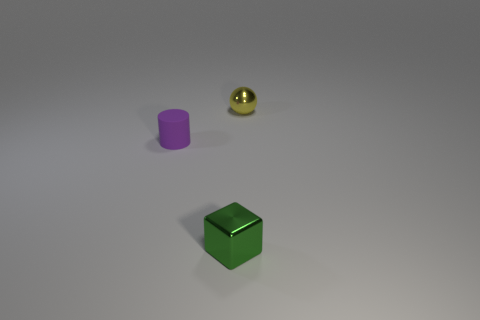Is there anything else that is made of the same material as the cylinder?
Make the answer very short. No. Are there any tiny green objects to the left of the yellow metal thing behind the small purple matte cylinder?
Provide a short and direct response. Yes. What number of things are small metal things behind the purple matte thing or tiny things to the right of the green metallic block?
Make the answer very short. 1. Is there any other thing that has the same color as the small cube?
Your answer should be very brief. No. The shiny thing in front of the metal object that is behind the metallic thing on the left side of the yellow metal ball is what color?
Offer a very short reply. Green. There is a thing that is both behind the small shiny block and in front of the small yellow thing; what material is it?
Provide a succinct answer. Rubber. Are any large green matte cylinders visible?
Offer a very short reply. No. There is a object on the right side of the metallic thing that is in front of the object that is behind the small purple matte thing; what size is it?
Keep it short and to the point. Small. There is a yellow metallic ball; are there any objects left of it?
Ensure brevity in your answer.  Yes. What size is the object that is the same material as the yellow sphere?
Provide a succinct answer. Small. 